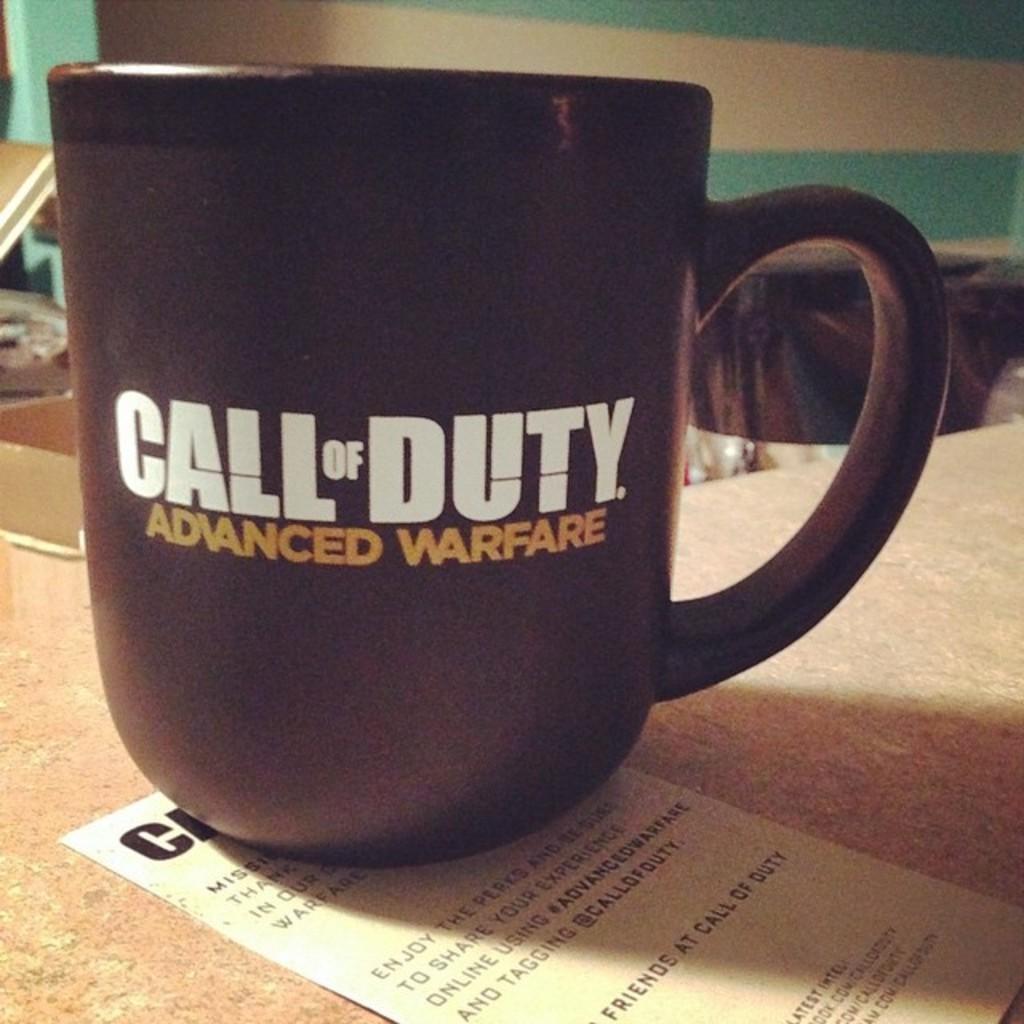Which call of duty is this on the mug?
Provide a short and direct response. Advanced warfare. What type of warfare is mentioned on the cup?
Give a very brief answer. Advanced. 